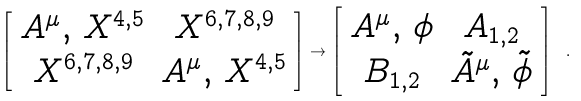Convert formula to latex. <formula><loc_0><loc_0><loc_500><loc_500>\left [ \begin{array} { c c } A ^ { \mu } , \, X ^ { 4 , 5 } & X ^ { 6 , 7 , 8 , 9 } \\ X ^ { 6 , 7 , 8 , 9 } & A ^ { \mu } , \, X ^ { 4 , 5 } \end{array} \right ] \to \left [ \begin{array} { c c } A ^ { \mu } , \, \phi & A _ { 1 , 2 } \\ B _ { 1 , 2 } & \tilde { A } ^ { \mu } , \, \tilde { \phi } \end{array} \right ] \ .</formula> 